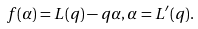<formula> <loc_0><loc_0><loc_500><loc_500>f ( \alpha ) = L ( q ) - q \alpha , \alpha = L ^ { \prime } ( q ) .</formula> 